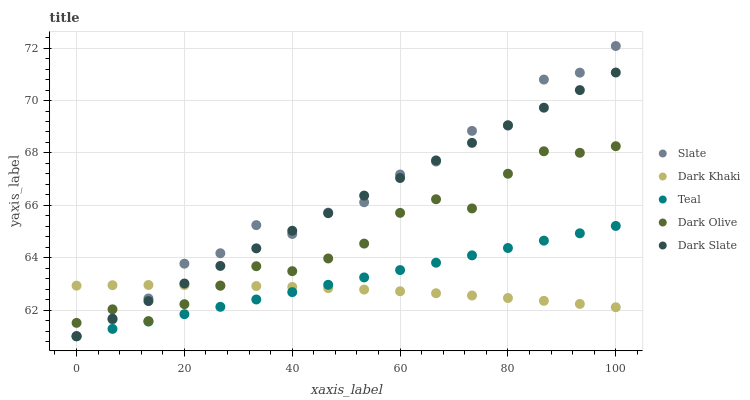Does Dark Khaki have the minimum area under the curve?
Answer yes or no. Yes. Does Slate have the maximum area under the curve?
Answer yes or no. Yes. Does Dark Slate have the minimum area under the curve?
Answer yes or no. No. Does Dark Slate have the maximum area under the curve?
Answer yes or no. No. Is Teal the smoothest?
Answer yes or no. Yes. Is Slate the roughest?
Answer yes or no. Yes. Is Dark Slate the smoothest?
Answer yes or no. No. Is Dark Slate the roughest?
Answer yes or no. No. Does Dark Slate have the lowest value?
Answer yes or no. Yes. Does Dark Olive have the lowest value?
Answer yes or no. No. Does Slate have the highest value?
Answer yes or no. Yes. Does Dark Slate have the highest value?
Answer yes or no. No. Is Teal less than Dark Olive?
Answer yes or no. Yes. Is Dark Olive greater than Teal?
Answer yes or no. Yes. Does Teal intersect Dark Slate?
Answer yes or no. Yes. Is Teal less than Dark Slate?
Answer yes or no. No. Is Teal greater than Dark Slate?
Answer yes or no. No. Does Teal intersect Dark Olive?
Answer yes or no. No. 